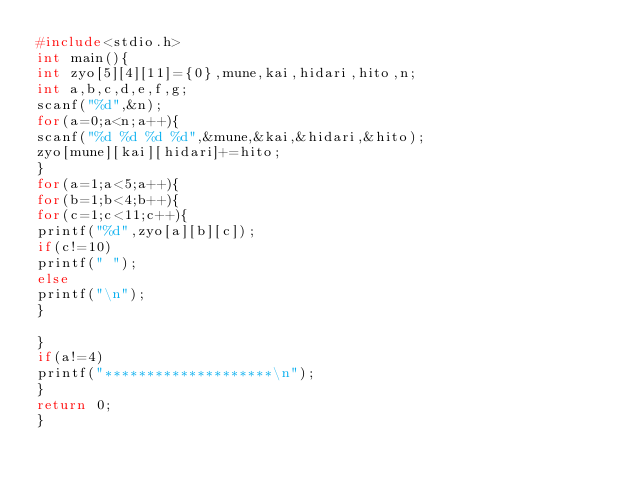<code> <loc_0><loc_0><loc_500><loc_500><_C_>#include<stdio.h>
int main(){
int zyo[5][4][11]={0},mune,kai,hidari,hito,n;
int a,b,c,d,e,f,g;
scanf("%d",&n);
for(a=0;a<n;a++){
scanf("%d %d %d %d",&mune,&kai,&hidari,&hito);
zyo[mune][kai][hidari]+=hito;
}
for(a=1;a<5;a++){
for(b=1;b<4;b++){
for(c=1;c<11;c++){
printf("%d",zyo[a][b][c]);
if(c!=10)
printf(" ");
else
printf("\n");
}

}
if(a!=4)
printf("********************\n");
}
return 0;
}</code> 